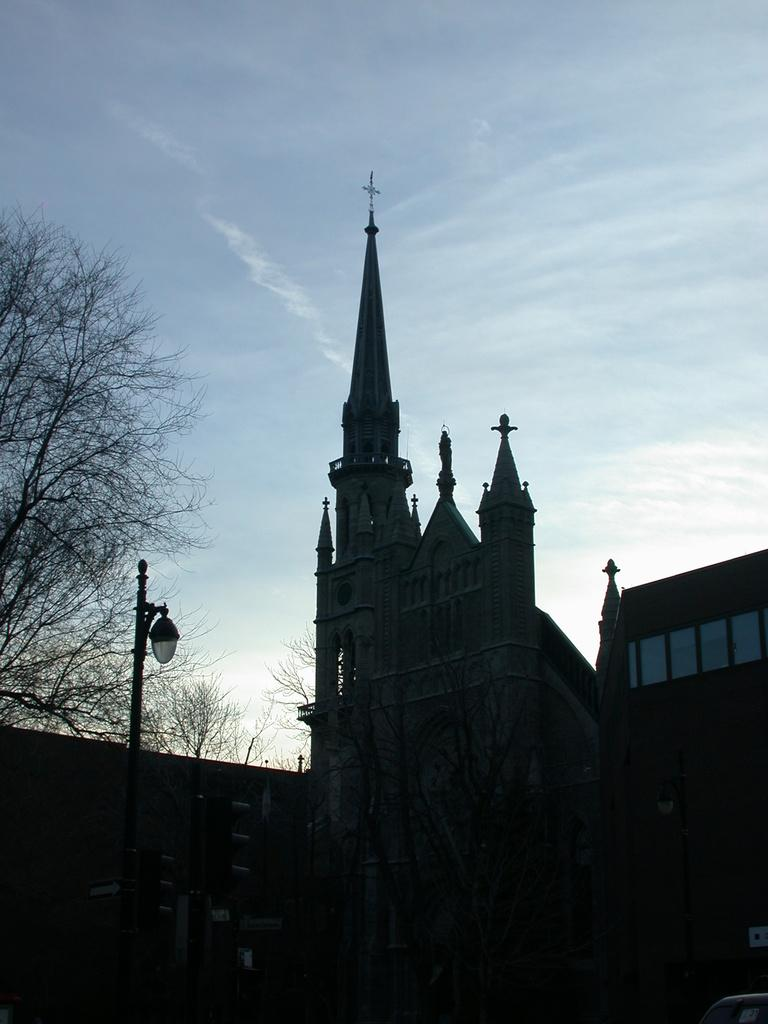What type of structure is the main subject of the image? There is a castle in the image. What is located to the left of the castle? There is a wall to the left of the castle. Are there any other objects or structures near the wall? Yes, there is a pole and a tree near the wall. What can be seen at the top of the image? The sky is visible at the top of the image. Reasoning: Let' Let's think step by step in order to produce the conversation. We start by identifying the main subject of the image, which is the castle. Then, we describe the surrounding objects and structures, such as the wall, pole, and tree. Finally, we mention the sky, which is visible at the top of the image. Each question is designed to elicit a specific detail about the image that is known from the provided facts. Absurd Question/Answer: Where is the beggar sitting in the image? There is no beggar present in the image. What type of tool is being used to fix the lunchroom in the image? There is: There is no lunchroom or tool present in the image. 